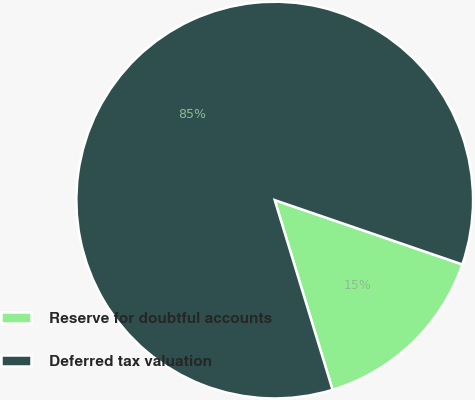Convert chart. <chart><loc_0><loc_0><loc_500><loc_500><pie_chart><fcel>Reserve for doubtful accounts<fcel>Deferred tax valuation<nl><fcel>15.03%<fcel>84.97%<nl></chart> 